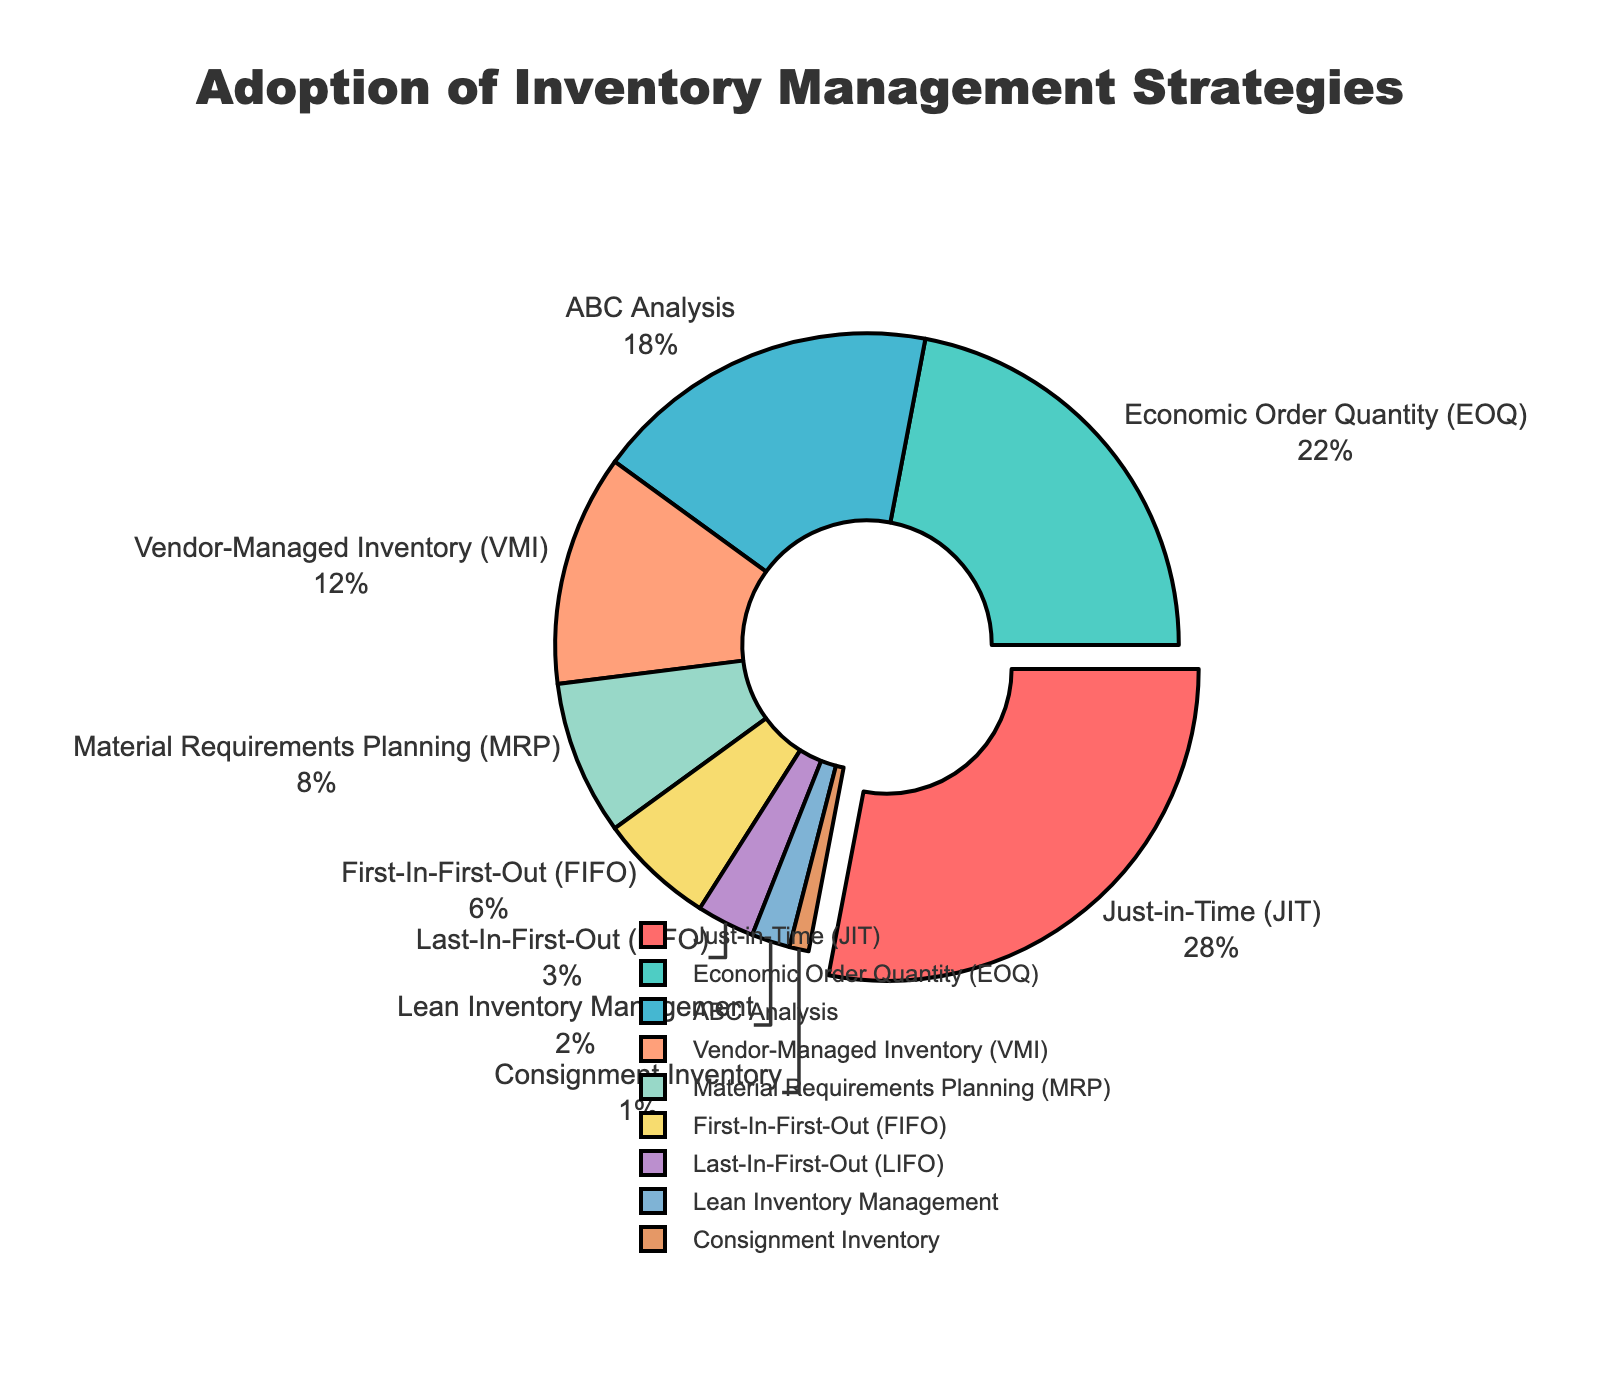What's the most adopted inventory management strategy? The most adopted inventory management strategy is the one with the highest percentage. The slice of the pie chart that is slightly pulled out represents the highest percentage.
Answer: Just-in-Time (JIT) Which two strategies make up half of the total percentage? To find the two strategies that cumulatively make up half, add their percentages. JIT has 28% and EOQ has 22%. 28% + 22% = 50%.
Answer: Just-in-Time (JIT) and Economic Order Quantity (EOQ) Which strategy has the least adoption rate? The strategy with the least adoption rate is the one with the smallest percentage. Look for the smallest slice in the pie chart.
Answer: Consignment Inventory What is the combined percentage of ABC Analysis and Vendor-Managed Inventory (VMI) strategies? Add the percentages of ABC Analysis and VMI: 18% + 12% = 30%.
Answer: 30% How does the adoption of First-In-First-Out (FIFO) compare to Last-In-First-Out (LIFO)? Compare their percentages: FIFO has 6% and LIFO has 3%. FIFO's percentage is double that of LIFO.
Answer: FIFO is twice as much as LIFO What visual element helps to easily identify the most adopted strategy in the chart? The pie slice of the most adopted strategy is slightly pulled out, which makes it stand out visually.
Answer: The slice is pulled out What is the percentage difference between the MRP and lean inventory management strategies? Calculate the difference between their percentages: MRP (8%) - Lean Inventory Management (2%) = 6%.
Answer: 6% Are there more companies adopting VMI or MRP? Compare the percentages directly from the figure: VMI has 12%, and MRP has 8%. VMI's percentage is higher.
Answer: VMI What fraction of the chart represents the JIT strategy? The JIT strategy represents 28% of the chart. To convert this to a fraction: 28/100 simplifies to 7/25.
Answer: 7/25 Which three strategies together account for 48% of the total percentage? Add the percentages of the strategies to find a combination that sums to 48%. JIT (28%) + EOQ (22%) = 50% is too high, but JIT (28%) + ABC Analysis (18%) + Lean Inventory Management (2%) = 48%.
Answer: Just-in-Time (JIT), ABC Analysis, and Lean Inventory Management 